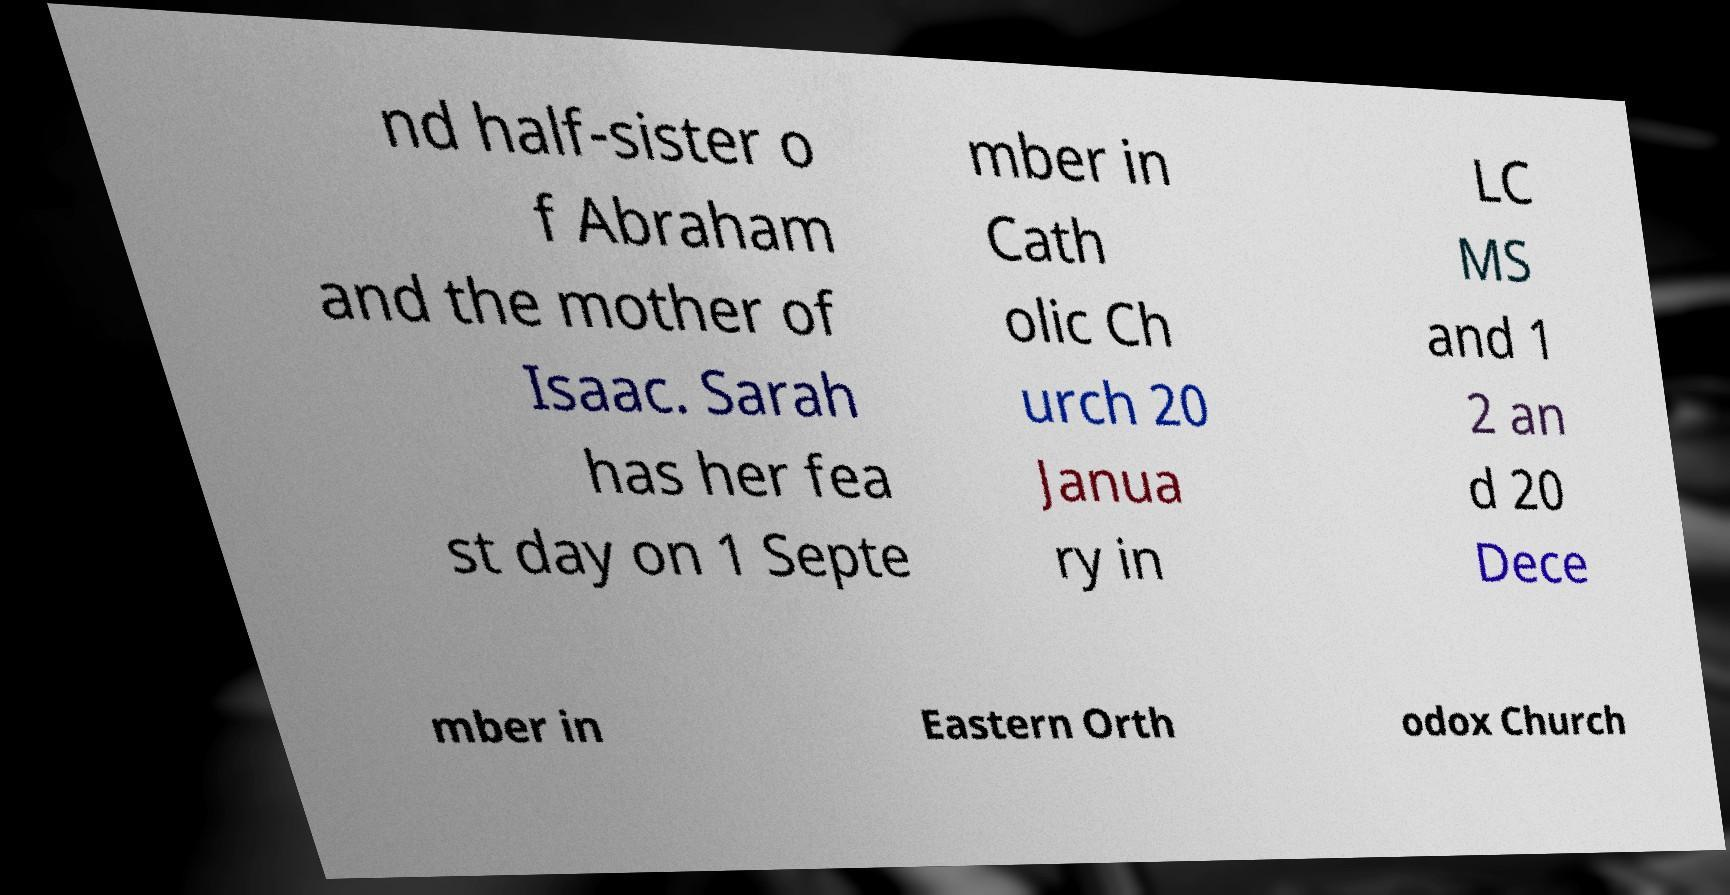I need the written content from this picture converted into text. Can you do that? nd half-sister o f Abraham and the mother of Isaac. Sarah has her fea st day on 1 Septe mber in Cath olic Ch urch 20 Janua ry in LC MS and 1 2 an d 20 Dece mber in Eastern Orth odox Church 